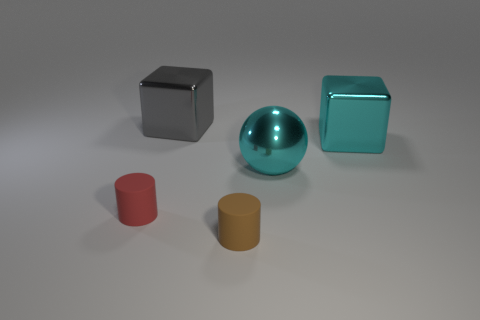Are there any shiny things of the same color as the sphere?
Offer a terse response. Yes. The brown rubber object that is in front of the big block that is to the right of the large gray cube is what shape?
Your response must be concise. Cylinder. Does the gray object have the same shape as the tiny red rubber thing?
Give a very brief answer. No. What material is the thing that is the same color as the sphere?
Give a very brief answer. Metal. There is a cube behind the metal thing right of the big ball; what number of big metallic objects are right of it?
Offer a very short reply. 2. The tiny object that is the same material as the brown cylinder is what shape?
Provide a short and direct response. Cylinder. What is the material of the large block to the left of the cyan metallic ball that is to the left of the large shiny thing on the right side of the cyan sphere?
Give a very brief answer. Metal. How many things are spheres that are right of the small red rubber object or tiny red objects?
Your answer should be compact. 2. What number of other things are the same shape as the brown rubber object?
Ensure brevity in your answer.  1. Is the number of shiny balls behind the cyan metal sphere greater than the number of small red matte spheres?
Offer a very short reply. No. 